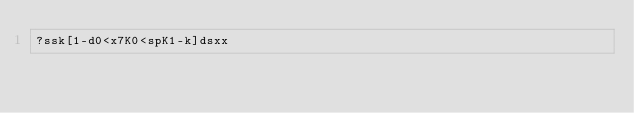<code> <loc_0><loc_0><loc_500><loc_500><_dc_>?ssk[1-d0<x7K0<spK1-k]dsxx</code> 